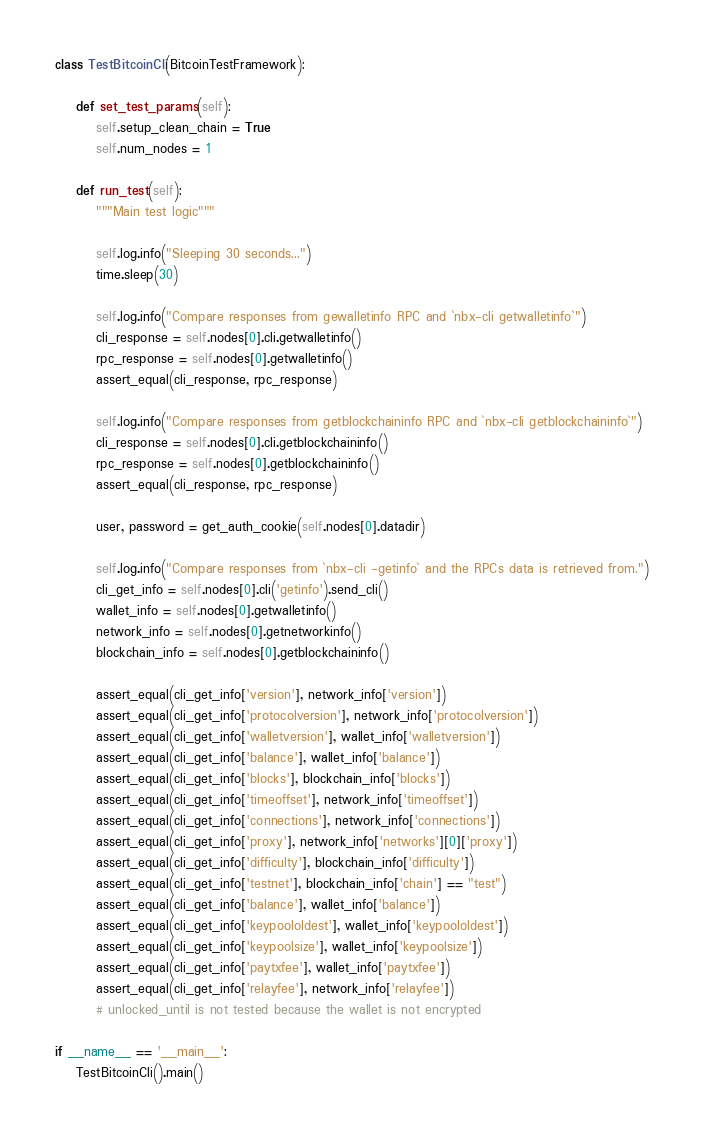<code> <loc_0><loc_0><loc_500><loc_500><_Python_>
class TestBitcoinCli(BitcoinTestFramework):

    def set_test_params(self):
        self.setup_clean_chain = True
        self.num_nodes = 1

    def run_test(self):
        """Main test logic"""

        self.log.info("Sleeping 30 seconds...")
        time.sleep(30)

        self.log.info("Compare responses from gewalletinfo RPC and `nbx-cli getwalletinfo`")
        cli_response = self.nodes[0].cli.getwalletinfo()
        rpc_response = self.nodes[0].getwalletinfo()
        assert_equal(cli_response, rpc_response)

        self.log.info("Compare responses from getblockchaininfo RPC and `nbx-cli getblockchaininfo`")
        cli_response = self.nodes[0].cli.getblockchaininfo()
        rpc_response = self.nodes[0].getblockchaininfo()
        assert_equal(cli_response, rpc_response)

        user, password = get_auth_cookie(self.nodes[0].datadir)

        self.log.info("Compare responses from `nbx-cli -getinfo` and the RPCs data is retrieved from.")
        cli_get_info = self.nodes[0].cli('getinfo').send_cli()
        wallet_info = self.nodes[0].getwalletinfo()
        network_info = self.nodes[0].getnetworkinfo()
        blockchain_info = self.nodes[0].getblockchaininfo()

        assert_equal(cli_get_info['version'], network_info['version'])
        assert_equal(cli_get_info['protocolversion'], network_info['protocolversion'])
        assert_equal(cli_get_info['walletversion'], wallet_info['walletversion'])
        assert_equal(cli_get_info['balance'], wallet_info['balance'])
        assert_equal(cli_get_info['blocks'], blockchain_info['blocks'])
        assert_equal(cli_get_info['timeoffset'], network_info['timeoffset'])
        assert_equal(cli_get_info['connections'], network_info['connections'])
        assert_equal(cli_get_info['proxy'], network_info['networks'][0]['proxy'])
        assert_equal(cli_get_info['difficulty'], blockchain_info['difficulty'])
        assert_equal(cli_get_info['testnet'], blockchain_info['chain'] == "test")
        assert_equal(cli_get_info['balance'], wallet_info['balance'])
        assert_equal(cli_get_info['keypoololdest'], wallet_info['keypoololdest'])
        assert_equal(cli_get_info['keypoolsize'], wallet_info['keypoolsize'])
        assert_equal(cli_get_info['paytxfee'], wallet_info['paytxfee'])
        assert_equal(cli_get_info['relayfee'], network_info['relayfee'])
        # unlocked_until is not tested because the wallet is not encrypted

if __name__ == '__main__':
    TestBitcoinCli().main()
</code> 